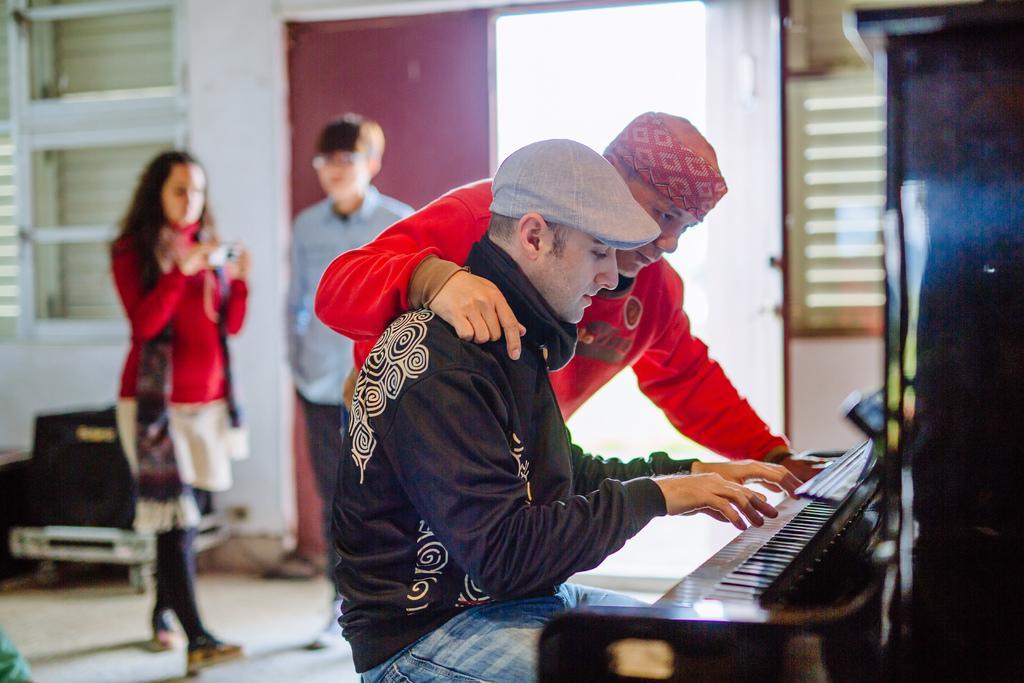In one or two sentences, can you explain what this image depicts? This picture is taken inside the room, In the right side there is a piano which is in black color and there is a person sitting and playing the piano and in the background there are some people standing and there is a red color door and white color wall. 